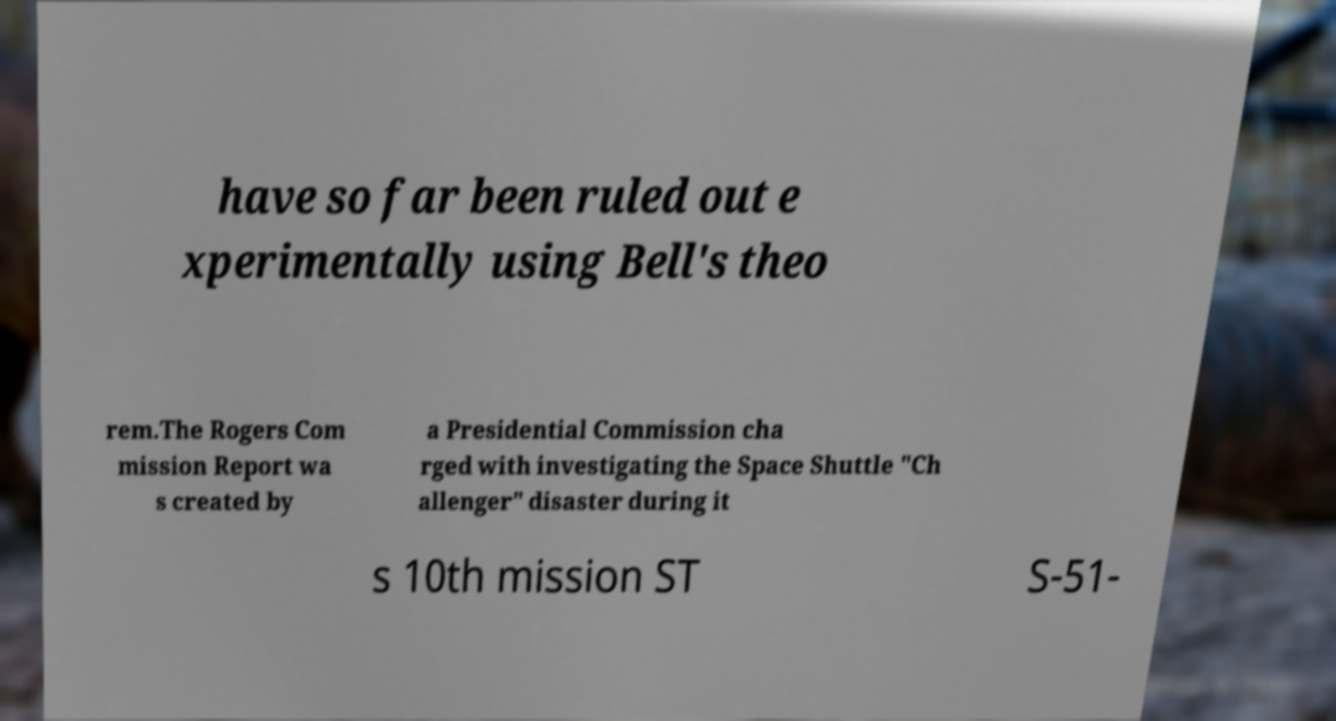Please read and relay the text visible in this image. What does it say? have so far been ruled out e xperimentally using Bell's theo rem.The Rogers Com mission Report wa s created by a Presidential Commission cha rged with investigating the Space Shuttle "Ch allenger" disaster during it s 10th mission ST S-51- 